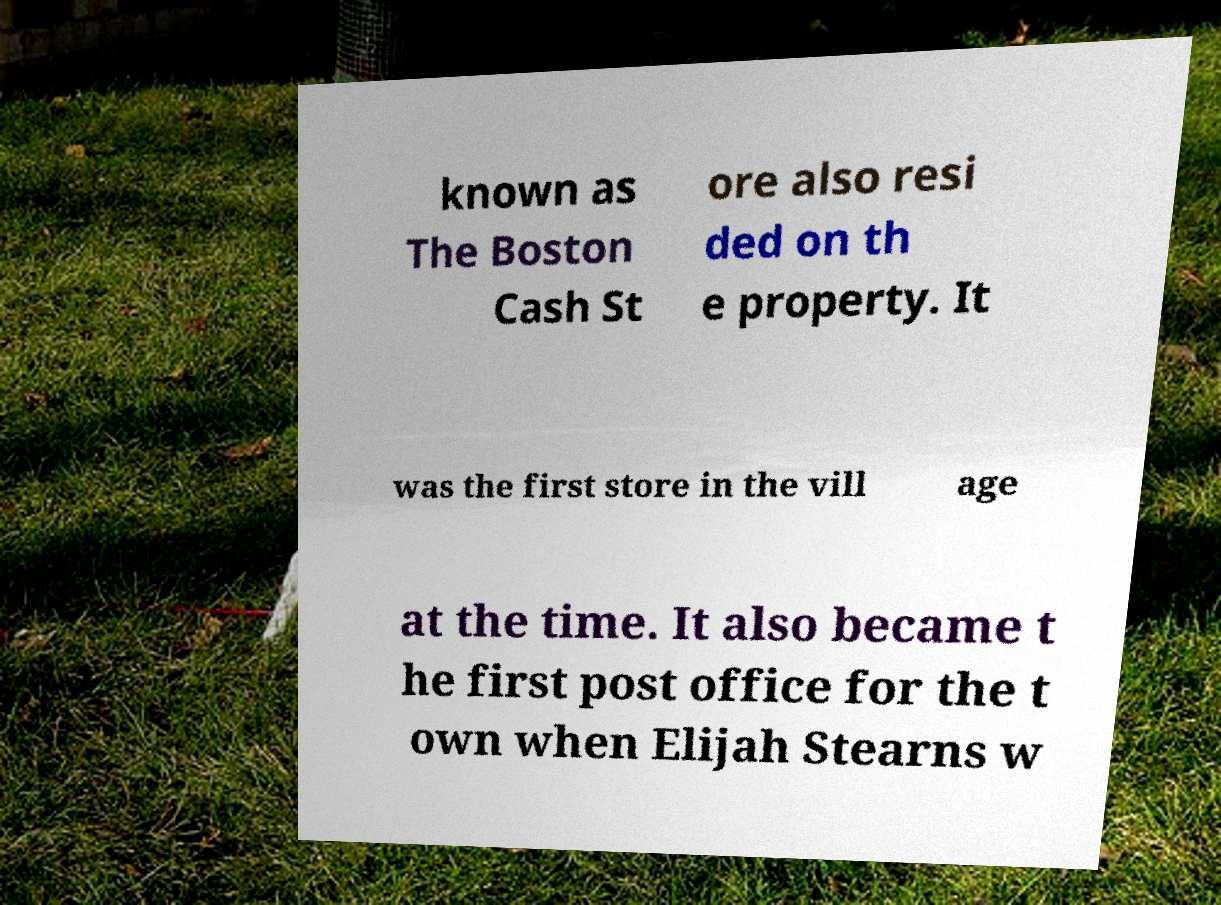Please identify and transcribe the text found in this image. known as The Boston Cash St ore also resi ded on th e property. It was the first store in the vill age at the time. It also became t he first post office for the t own when Elijah Stearns w 